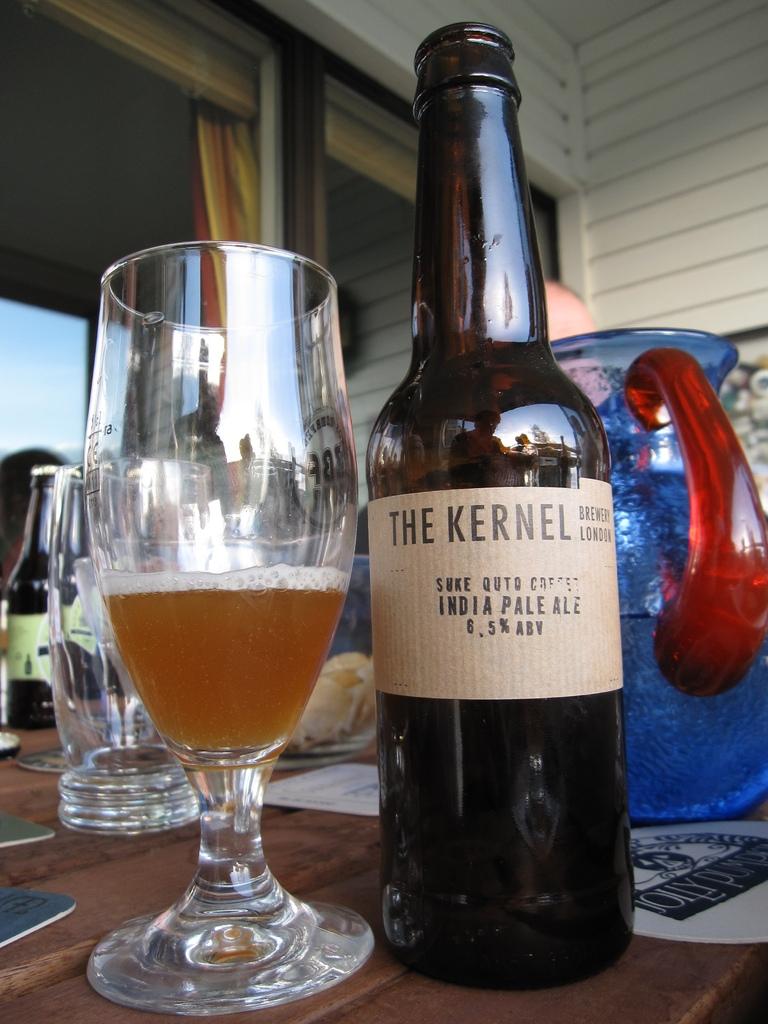What kind of ale is this?
Your answer should be very brief. India pale ale. 